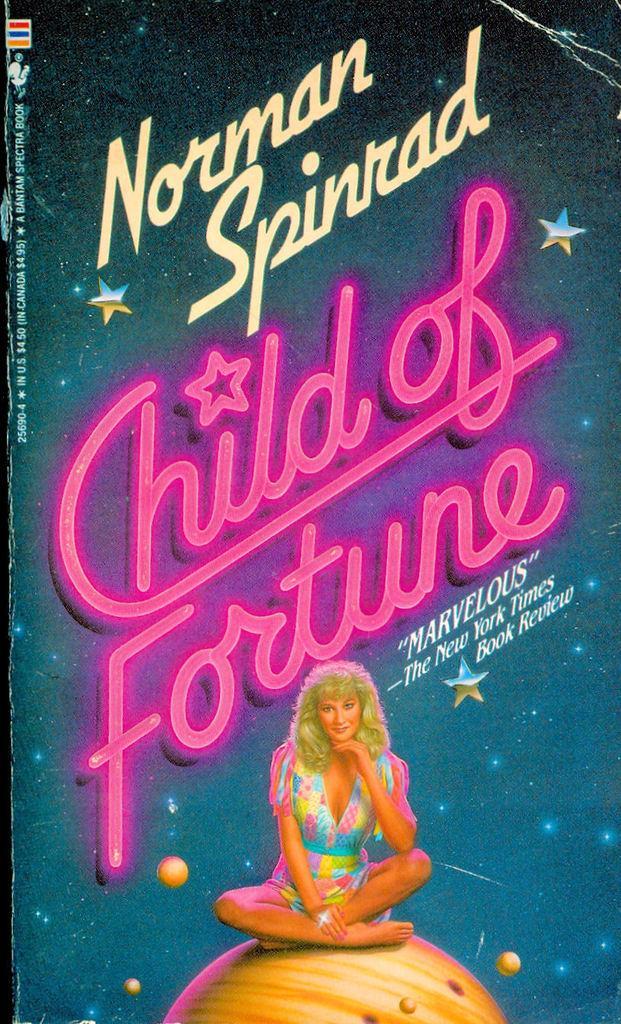Could you give a brief overview of what you see in this image? In this image I see a poster on which there are words written and I see stars and I see a round color thing which is light brown in color and I see a woman who is sitting on it and she is wearing colorful dress. 